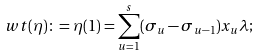Convert formula to latex. <formula><loc_0><loc_0><loc_500><loc_500>\ w t ( \eta ) \colon = \eta ( 1 ) = \sum _ { u = 1 } ^ { s } ( \sigma _ { u } - \sigma _ { u - 1 } ) x _ { u } \lambda ;</formula> 